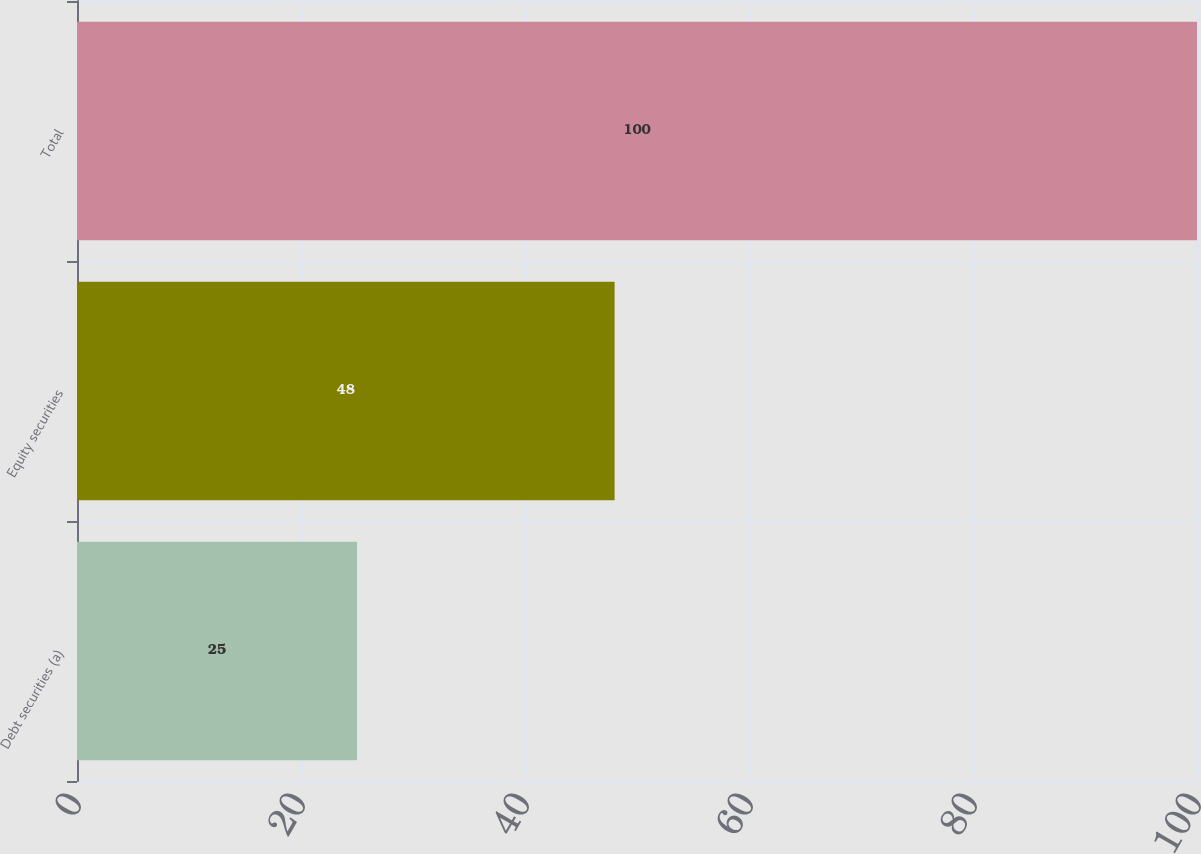Convert chart. <chart><loc_0><loc_0><loc_500><loc_500><bar_chart><fcel>Debt securities (a)<fcel>Equity securities<fcel>Total<nl><fcel>25<fcel>48<fcel>100<nl></chart> 